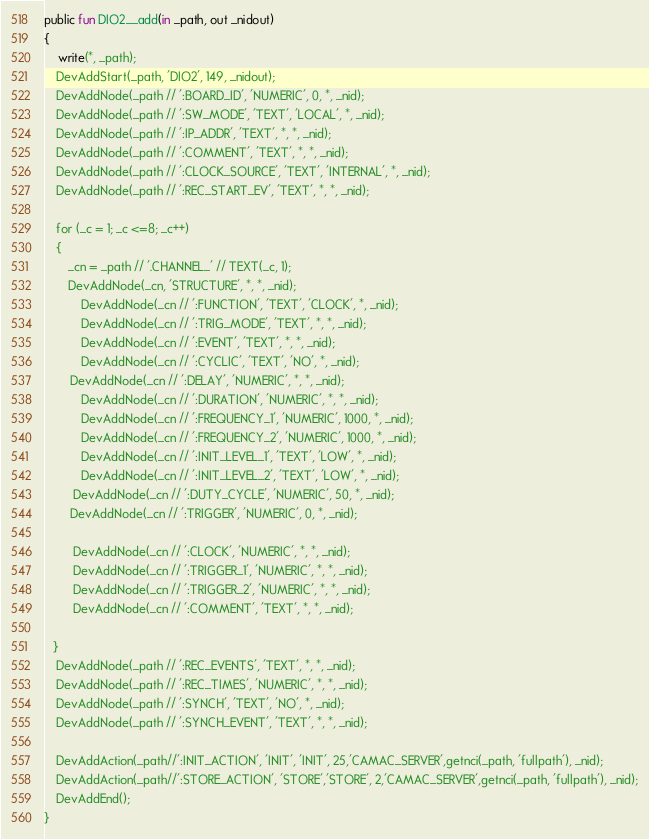<code> <loc_0><loc_0><loc_500><loc_500><_SML_>public fun DIO2__add(in _path, out _nidout)
{
    write(*, _path);
    DevAddStart(_path, 'DIO2', 149, _nidout);
    DevAddNode(_path // ':BOARD_ID', 'NUMERIC', 0, *, _nid);
    DevAddNode(_path // ':SW_MODE', 'TEXT', 'LOCAL', *, _nid);
    DevAddNode(_path // ':IP_ADDR', 'TEXT', *, *, _nid);
    DevAddNode(_path // ':COMMENT', 'TEXT', *, *, _nid);
    DevAddNode(_path // ':CLOCK_SOURCE', 'TEXT', 'INTERNAL', *, _nid);
    DevAddNode(_path // ':REC_START_EV', 'TEXT', *, *, _nid);

    for (_c = 1; _c <=8; _c++)
    {
        _cn = _path // '.CHANNEL_' // TEXT(_c, 1);
        DevAddNode(_cn, 'STRUCTURE', *, *, _nid);
   		DevAddNode(_cn // ':FUNCTION', 'TEXT', 'CLOCK', *, _nid);
   		DevAddNode(_cn // ':TRIG_MODE', 'TEXT', *, *, _nid);
   		DevAddNode(_cn // ':EVENT', 'TEXT', *, *, _nid);
   		DevAddNode(_cn // ':CYCLIC', 'TEXT', 'NO', *, _nid);
    	DevAddNode(_cn // ':DELAY', 'NUMERIC', *, *, _nid);
   		DevAddNode(_cn // ':DURATION', 'NUMERIC', *, *, _nid);
   		DevAddNode(_cn // ':FREQUENCY_1', 'NUMERIC', 1000, *, _nid);
   		DevAddNode(_cn // ':FREQUENCY_2', 'NUMERIC', 1000, *, _nid);
   		DevAddNode(_cn // ':INIT_LEVEL_1', 'TEXT', 'LOW', *, _nid);
   		DevAddNode(_cn // ':INIT_LEVEL_2', 'TEXT', 'LOW', *, _nid);
     	DevAddNode(_cn // ':DUTY_CYCLE', 'NUMERIC', 50, *, _nid);
    	DevAddNode(_cn // ':TRIGGER', 'NUMERIC', 0, *, _nid);

     	DevAddNode(_cn // ':CLOCK', 'NUMERIC', *, *, _nid);
     	DevAddNode(_cn // ':TRIGGER_1', 'NUMERIC', *, *, _nid);
     	DevAddNode(_cn // ':TRIGGER_2', 'NUMERIC', *, *, _nid);
     	DevAddNode(_cn // ':COMMENT', 'TEXT', *, *, _nid);

   }
    DevAddNode(_path // ':REC_EVENTS', 'TEXT', *, *, _nid);
    DevAddNode(_path // ':REC_TIMES', 'NUMERIC', *, *, _nid);
    DevAddNode(_path // ':SYNCH', 'TEXT', 'NO', *, _nid);
    DevAddNode(_path // ':SYNCH_EVENT', 'TEXT', *, *, _nid);

    DevAddAction(_path//':INIT_ACTION', 'INIT', 'INIT', 25,'CAMAC_SERVER',getnci(_path, 'fullpath'), _nid);
    DevAddAction(_path//':STORE_ACTION', 'STORE','STORE', 2,'CAMAC_SERVER',getnci(_path, 'fullpath'), _nid);
    DevAddEnd();
}


</code> 